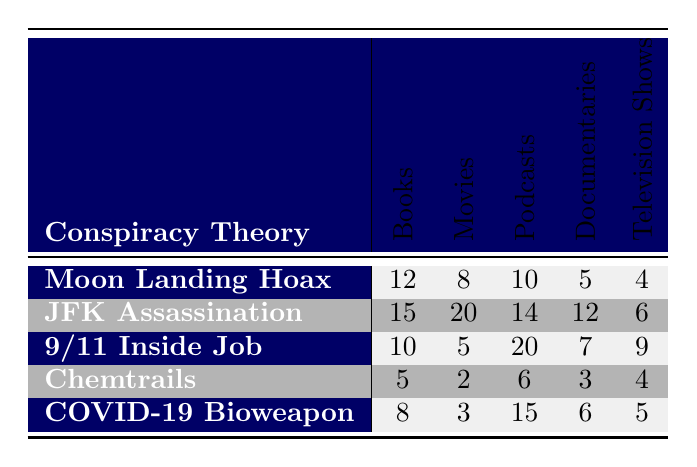What is the total frequency of the "JFK Assassination" theory across all media formats? To find the total frequency, sum the values for "JFK Assassination" across all media formats: 15 (Books) + 20 (Movies) + 14 (Podcasts) + 12 (Documentaries) + 6 (Television Shows) = 67
Answer: 67 Which media format has the highest frequency for the "Moon Landing Hoax" theory? Looking at the values for the "Moon Landing Hoax," the highest is 12 in Books, 10 in Podcasts, 8 in Movies, 5 in Documentaries, and 4 in Television Shows. Therefore, the highest frequency is 12 in Books.
Answer: Books Is the frequency of the "COVID-19 Bioweapon" theory higher in Podcasts than in Movies? The frequency for "COVID-19 Bioweapon" in Podcasts is 15, while in Movies it is 3. Since 15 > 3, the frequency in Podcasts is higher.
Answer: Yes What is the average frequency of conspiracy theory references in Documentaries? To calculate the average frequency in Documentaries, add the values: 5 (Moon Landing Hoax) + 12 (JFK Assassination) + 7 (9/11 Inside Job) + 3 (Chemtrails) + 6 (COVID-19 Bioweapon) = 33. There are 5 theories, so the average is 33/5 = 6.6.
Answer: 6.6 Which theory has the least references in Movies? Checking the values for each theory in Movies: Moon Landing Hoax (8), JFK Assassination (20), 9/11 Inside Job (5), Chemtrails (2), COVID-19 Bioweapon (3). The least references in Movies is 2 for Chemtrails.
Answer: Chemtrails What is the difference in total frequency between the "JFK Assassination" and the "9/11 Inside Job" theories? First, find the total frequency for both theories: JFK Assassination = 67 and 9/11 Inside Job = 51 (10 + 5 + 20 + 7 + 9). Now, calculate the difference: 67 - 51 = 16.
Answer: 16 Which theory appears the most frequently overall? To determine this, calculate the total for each theory: Moon Landing Hoax = 49, JFK Assassination = 67, 9/11 Inside Job = 51, Chemtrails = 20, COVID-19 Bioweapon = 37. The "JFK Assassination" theory appears most frequently at 67.
Answer: JFK Assassination Is the frequency of conspiracy theories in Television Shows generally low compared to the other media formats? Summing the frequencies in Television Shows gives: 4 (Moon Landing Hoax), 6 (JFK Assassination), 9 (9/11 Inside Job), 4 (Chemtrails), 5 (COVID-19 Bioweapon) = 28. Compared to totals in other formats, this appears lower overall.
Answer: Yes 